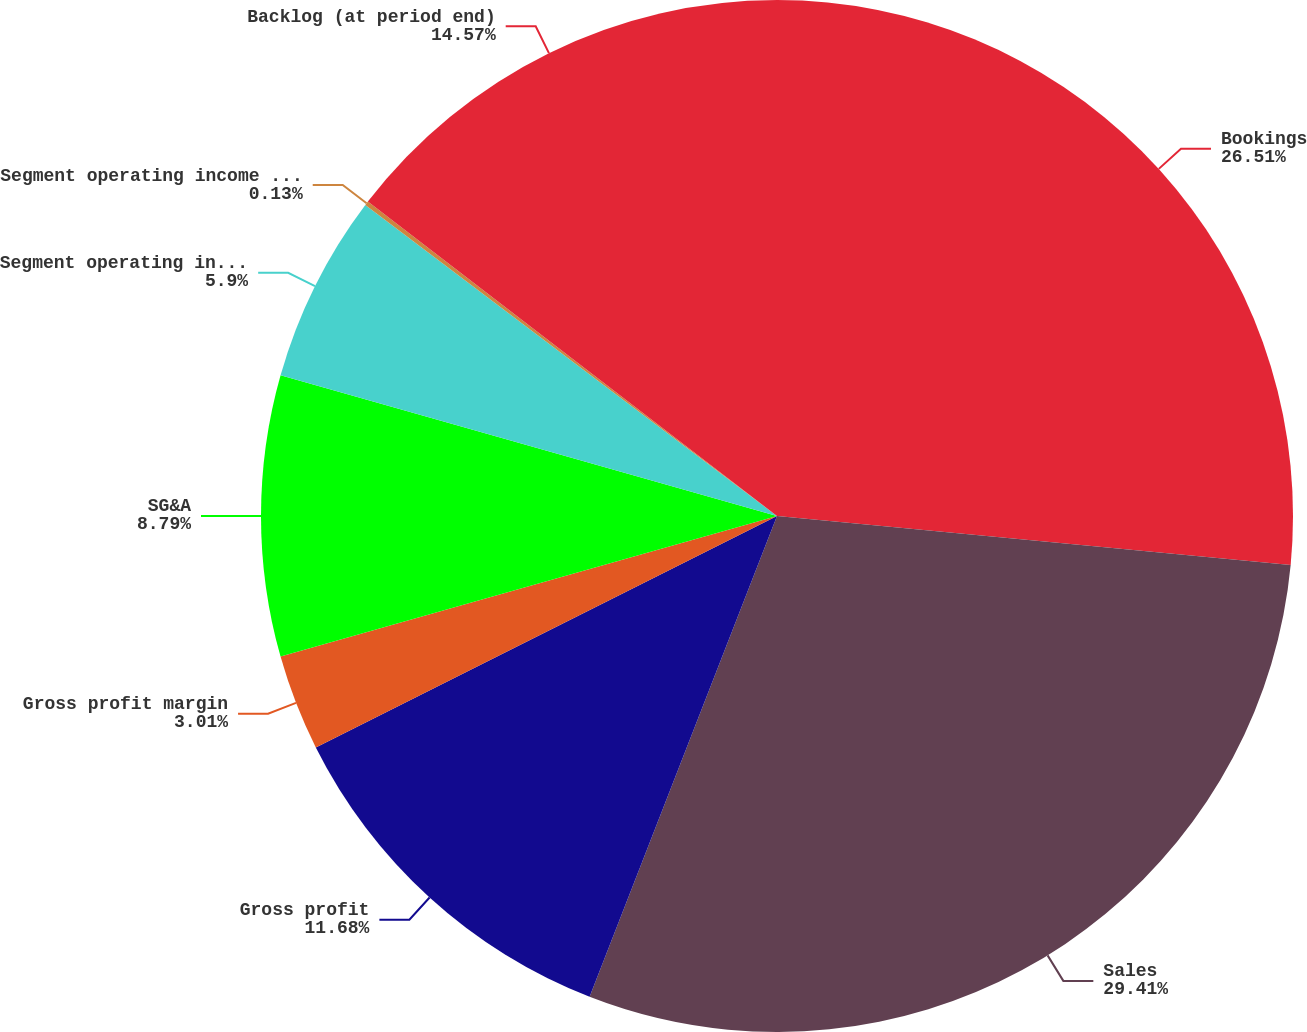Convert chart to OTSL. <chart><loc_0><loc_0><loc_500><loc_500><pie_chart><fcel>Bookings<fcel>Sales<fcel>Gross profit<fcel>Gross profit margin<fcel>SG&A<fcel>Segment operating income<fcel>Segment operating income as a<fcel>Backlog (at period end)<nl><fcel>26.51%<fcel>29.4%<fcel>11.68%<fcel>3.01%<fcel>8.79%<fcel>5.9%<fcel>0.13%<fcel>14.57%<nl></chart> 